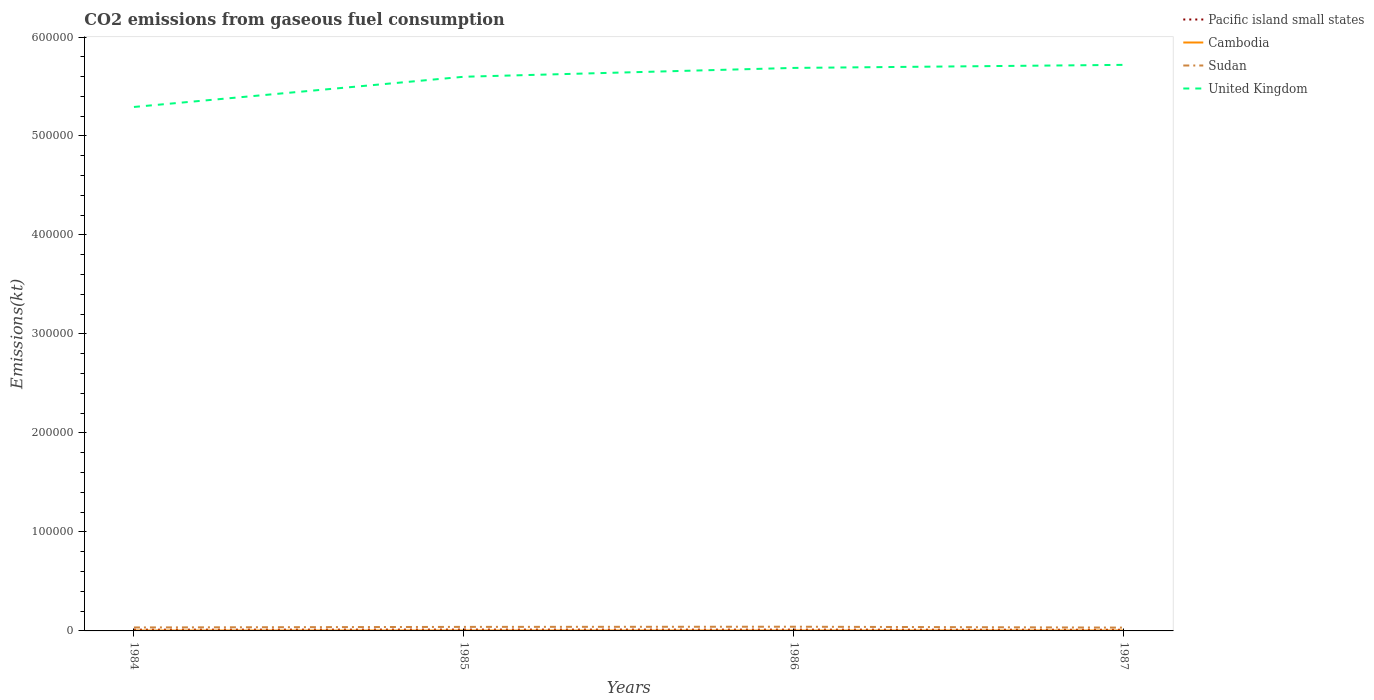How many different coloured lines are there?
Offer a terse response. 4. Does the line corresponding to Pacific island small states intersect with the line corresponding to Cambodia?
Give a very brief answer. No. Is the number of lines equal to the number of legend labels?
Offer a terse response. Yes. Across all years, what is the maximum amount of CO2 emitted in Pacific island small states?
Your answer should be compact. 1136.17. What is the total amount of CO2 emitted in United Kingdom in the graph?
Keep it short and to the point. -3091.28. What is the difference between the highest and the second highest amount of CO2 emitted in Pacific island small states?
Make the answer very short. 172.63. How many lines are there?
Give a very brief answer. 4. What is the difference between two consecutive major ticks on the Y-axis?
Ensure brevity in your answer.  1.00e+05. Are the values on the major ticks of Y-axis written in scientific E-notation?
Keep it short and to the point. No. Does the graph contain any zero values?
Make the answer very short. No. Where does the legend appear in the graph?
Keep it short and to the point. Top right. How many legend labels are there?
Provide a succinct answer. 4. How are the legend labels stacked?
Ensure brevity in your answer.  Vertical. What is the title of the graph?
Ensure brevity in your answer.  CO2 emissions from gaseous fuel consumption. Does "Monaco" appear as one of the legend labels in the graph?
Your response must be concise. No. What is the label or title of the Y-axis?
Give a very brief answer. Emissions(kt). What is the Emissions(kt) in Pacific island small states in 1984?
Your response must be concise. 1228.51. What is the Emissions(kt) of Cambodia in 1984?
Provide a succinct answer. 410.7. What is the Emissions(kt) of Sudan in 1984?
Give a very brief answer. 3505.65. What is the Emissions(kt) in United Kingdom in 1984?
Give a very brief answer. 5.29e+05. What is the Emissions(kt) in Pacific island small states in 1985?
Keep it short and to the point. 1308.8. What is the Emissions(kt) in Cambodia in 1985?
Your answer should be very brief. 418.04. What is the Emissions(kt) in Sudan in 1985?
Make the answer very short. 4074.04. What is the Emissions(kt) in United Kingdom in 1985?
Offer a very short reply. 5.60e+05. What is the Emissions(kt) of Pacific island small states in 1986?
Make the answer very short. 1268.66. What is the Emissions(kt) in Cambodia in 1986?
Provide a short and direct response. 432.71. What is the Emissions(kt) in Sudan in 1986?
Make the answer very short. 4250.05. What is the Emissions(kt) of United Kingdom in 1986?
Keep it short and to the point. 5.69e+05. What is the Emissions(kt) of Pacific island small states in 1987?
Ensure brevity in your answer.  1136.17. What is the Emissions(kt) in Cambodia in 1987?
Make the answer very short. 436.37. What is the Emissions(kt) of Sudan in 1987?
Your response must be concise. 3351.64. What is the Emissions(kt) in United Kingdom in 1987?
Provide a short and direct response. 5.72e+05. Across all years, what is the maximum Emissions(kt) of Pacific island small states?
Your answer should be compact. 1308.8. Across all years, what is the maximum Emissions(kt) of Cambodia?
Keep it short and to the point. 436.37. Across all years, what is the maximum Emissions(kt) in Sudan?
Ensure brevity in your answer.  4250.05. Across all years, what is the maximum Emissions(kt) in United Kingdom?
Provide a short and direct response. 5.72e+05. Across all years, what is the minimum Emissions(kt) of Pacific island small states?
Keep it short and to the point. 1136.17. Across all years, what is the minimum Emissions(kt) of Cambodia?
Your answer should be very brief. 410.7. Across all years, what is the minimum Emissions(kt) of Sudan?
Give a very brief answer. 3351.64. Across all years, what is the minimum Emissions(kt) in United Kingdom?
Provide a short and direct response. 5.29e+05. What is the total Emissions(kt) in Pacific island small states in the graph?
Keep it short and to the point. 4942.14. What is the total Emissions(kt) in Cambodia in the graph?
Give a very brief answer. 1697.82. What is the total Emissions(kt) in Sudan in the graph?
Keep it short and to the point. 1.52e+04. What is the total Emissions(kt) of United Kingdom in the graph?
Offer a very short reply. 2.23e+06. What is the difference between the Emissions(kt) of Pacific island small states in 1984 and that in 1985?
Keep it short and to the point. -80.29. What is the difference between the Emissions(kt) of Cambodia in 1984 and that in 1985?
Your answer should be compact. -7.33. What is the difference between the Emissions(kt) of Sudan in 1984 and that in 1985?
Ensure brevity in your answer.  -568.38. What is the difference between the Emissions(kt) of United Kingdom in 1984 and that in 1985?
Your response must be concise. -3.05e+04. What is the difference between the Emissions(kt) of Pacific island small states in 1984 and that in 1986?
Your answer should be compact. -40.15. What is the difference between the Emissions(kt) in Cambodia in 1984 and that in 1986?
Provide a succinct answer. -22. What is the difference between the Emissions(kt) of Sudan in 1984 and that in 1986?
Your answer should be compact. -744.4. What is the difference between the Emissions(kt) in United Kingdom in 1984 and that in 1986?
Give a very brief answer. -3.94e+04. What is the difference between the Emissions(kt) of Pacific island small states in 1984 and that in 1987?
Give a very brief answer. 92.34. What is the difference between the Emissions(kt) in Cambodia in 1984 and that in 1987?
Your response must be concise. -25.67. What is the difference between the Emissions(kt) in Sudan in 1984 and that in 1987?
Your answer should be very brief. 154.01. What is the difference between the Emissions(kt) of United Kingdom in 1984 and that in 1987?
Offer a very short reply. -4.25e+04. What is the difference between the Emissions(kt) of Pacific island small states in 1985 and that in 1986?
Give a very brief answer. 40.15. What is the difference between the Emissions(kt) of Cambodia in 1985 and that in 1986?
Give a very brief answer. -14.67. What is the difference between the Emissions(kt) of Sudan in 1985 and that in 1986?
Your answer should be very brief. -176.02. What is the difference between the Emissions(kt) in United Kingdom in 1985 and that in 1986?
Your answer should be compact. -8921.81. What is the difference between the Emissions(kt) of Pacific island small states in 1985 and that in 1987?
Provide a succinct answer. 172.63. What is the difference between the Emissions(kt) of Cambodia in 1985 and that in 1987?
Make the answer very short. -18.34. What is the difference between the Emissions(kt) in Sudan in 1985 and that in 1987?
Your answer should be very brief. 722.4. What is the difference between the Emissions(kt) in United Kingdom in 1985 and that in 1987?
Ensure brevity in your answer.  -1.20e+04. What is the difference between the Emissions(kt) of Pacific island small states in 1986 and that in 1987?
Give a very brief answer. 132.49. What is the difference between the Emissions(kt) in Cambodia in 1986 and that in 1987?
Offer a very short reply. -3.67. What is the difference between the Emissions(kt) of Sudan in 1986 and that in 1987?
Offer a terse response. 898.41. What is the difference between the Emissions(kt) in United Kingdom in 1986 and that in 1987?
Provide a succinct answer. -3091.28. What is the difference between the Emissions(kt) of Pacific island small states in 1984 and the Emissions(kt) of Cambodia in 1985?
Keep it short and to the point. 810.47. What is the difference between the Emissions(kt) in Pacific island small states in 1984 and the Emissions(kt) in Sudan in 1985?
Your response must be concise. -2845.53. What is the difference between the Emissions(kt) of Pacific island small states in 1984 and the Emissions(kt) of United Kingdom in 1985?
Keep it short and to the point. -5.59e+05. What is the difference between the Emissions(kt) of Cambodia in 1984 and the Emissions(kt) of Sudan in 1985?
Your answer should be compact. -3663.33. What is the difference between the Emissions(kt) in Cambodia in 1984 and the Emissions(kt) in United Kingdom in 1985?
Ensure brevity in your answer.  -5.59e+05. What is the difference between the Emissions(kt) in Sudan in 1984 and the Emissions(kt) in United Kingdom in 1985?
Your answer should be very brief. -5.56e+05. What is the difference between the Emissions(kt) of Pacific island small states in 1984 and the Emissions(kt) of Cambodia in 1986?
Give a very brief answer. 795.8. What is the difference between the Emissions(kt) of Pacific island small states in 1984 and the Emissions(kt) of Sudan in 1986?
Your answer should be very brief. -3021.54. What is the difference between the Emissions(kt) in Pacific island small states in 1984 and the Emissions(kt) in United Kingdom in 1986?
Provide a succinct answer. -5.68e+05. What is the difference between the Emissions(kt) in Cambodia in 1984 and the Emissions(kt) in Sudan in 1986?
Give a very brief answer. -3839.35. What is the difference between the Emissions(kt) in Cambodia in 1984 and the Emissions(kt) in United Kingdom in 1986?
Keep it short and to the point. -5.68e+05. What is the difference between the Emissions(kt) of Sudan in 1984 and the Emissions(kt) of United Kingdom in 1986?
Give a very brief answer. -5.65e+05. What is the difference between the Emissions(kt) of Pacific island small states in 1984 and the Emissions(kt) of Cambodia in 1987?
Offer a terse response. 792.14. What is the difference between the Emissions(kt) of Pacific island small states in 1984 and the Emissions(kt) of Sudan in 1987?
Give a very brief answer. -2123.13. What is the difference between the Emissions(kt) of Pacific island small states in 1984 and the Emissions(kt) of United Kingdom in 1987?
Ensure brevity in your answer.  -5.71e+05. What is the difference between the Emissions(kt) of Cambodia in 1984 and the Emissions(kt) of Sudan in 1987?
Your answer should be compact. -2940.93. What is the difference between the Emissions(kt) of Cambodia in 1984 and the Emissions(kt) of United Kingdom in 1987?
Your response must be concise. -5.71e+05. What is the difference between the Emissions(kt) of Sudan in 1984 and the Emissions(kt) of United Kingdom in 1987?
Provide a succinct answer. -5.68e+05. What is the difference between the Emissions(kt) in Pacific island small states in 1985 and the Emissions(kt) in Cambodia in 1986?
Keep it short and to the point. 876.1. What is the difference between the Emissions(kt) in Pacific island small states in 1985 and the Emissions(kt) in Sudan in 1986?
Provide a short and direct response. -2941.25. What is the difference between the Emissions(kt) of Pacific island small states in 1985 and the Emissions(kt) of United Kingdom in 1986?
Your answer should be very brief. -5.67e+05. What is the difference between the Emissions(kt) in Cambodia in 1985 and the Emissions(kt) in Sudan in 1986?
Make the answer very short. -3832.01. What is the difference between the Emissions(kt) of Cambodia in 1985 and the Emissions(kt) of United Kingdom in 1986?
Make the answer very short. -5.68e+05. What is the difference between the Emissions(kt) of Sudan in 1985 and the Emissions(kt) of United Kingdom in 1986?
Keep it short and to the point. -5.65e+05. What is the difference between the Emissions(kt) in Pacific island small states in 1985 and the Emissions(kt) in Cambodia in 1987?
Your answer should be compact. 872.43. What is the difference between the Emissions(kt) in Pacific island small states in 1985 and the Emissions(kt) in Sudan in 1987?
Make the answer very short. -2042.83. What is the difference between the Emissions(kt) of Pacific island small states in 1985 and the Emissions(kt) of United Kingdom in 1987?
Provide a short and direct response. -5.71e+05. What is the difference between the Emissions(kt) in Cambodia in 1985 and the Emissions(kt) in Sudan in 1987?
Provide a short and direct response. -2933.6. What is the difference between the Emissions(kt) of Cambodia in 1985 and the Emissions(kt) of United Kingdom in 1987?
Your response must be concise. -5.71e+05. What is the difference between the Emissions(kt) in Sudan in 1985 and the Emissions(kt) in United Kingdom in 1987?
Keep it short and to the point. -5.68e+05. What is the difference between the Emissions(kt) in Pacific island small states in 1986 and the Emissions(kt) in Cambodia in 1987?
Give a very brief answer. 832.28. What is the difference between the Emissions(kt) in Pacific island small states in 1986 and the Emissions(kt) in Sudan in 1987?
Offer a very short reply. -2082.98. What is the difference between the Emissions(kt) in Pacific island small states in 1986 and the Emissions(kt) in United Kingdom in 1987?
Make the answer very short. -5.71e+05. What is the difference between the Emissions(kt) in Cambodia in 1986 and the Emissions(kt) in Sudan in 1987?
Ensure brevity in your answer.  -2918.93. What is the difference between the Emissions(kt) of Cambodia in 1986 and the Emissions(kt) of United Kingdom in 1987?
Make the answer very short. -5.71e+05. What is the difference between the Emissions(kt) of Sudan in 1986 and the Emissions(kt) of United Kingdom in 1987?
Provide a short and direct response. -5.68e+05. What is the average Emissions(kt) of Pacific island small states per year?
Provide a short and direct response. 1235.54. What is the average Emissions(kt) of Cambodia per year?
Give a very brief answer. 424.46. What is the average Emissions(kt) in Sudan per year?
Offer a terse response. 3795.34. What is the average Emissions(kt) in United Kingdom per year?
Ensure brevity in your answer.  5.57e+05. In the year 1984, what is the difference between the Emissions(kt) of Pacific island small states and Emissions(kt) of Cambodia?
Provide a short and direct response. 817.81. In the year 1984, what is the difference between the Emissions(kt) in Pacific island small states and Emissions(kt) in Sudan?
Your answer should be compact. -2277.14. In the year 1984, what is the difference between the Emissions(kt) in Pacific island small states and Emissions(kt) in United Kingdom?
Provide a short and direct response. -5.28e+05. In the year 1984, what is the difference between the Emissions(kt) in Cambodia and Emissions(kt) in Sudan?
Give a very brief answer. -3094.95. In the year 1984, what is the difference between the Emissions(kt) of Cambodia and Emissions(kt) of United Kingdom?
Your response must be concise. -5.29e+05. In the year 1984, what is the difference between the Emissions(kt) in Sudan and Emissions(kt) in United Kingdom?
Make the answer very short. -5.26e+05. In the year 1985, what is the difference between the Emissions(kt) in Pacific island small states and Emissions(kt) in Cambodia?
Your answer should be very brief. 890.77. In the year 1985, what is the difference between the Emissions(kt) of Pacific island small states and Emissions(kt) of Sudan?
Ensure brevity in your answer.  -2765.23. In the year 1985, what is the difference between the Emissions(kt) in Pacific island small states and Emissions(kt) in United Kingdom?
Provide a succinct answer. -5.59e+05. In the year 1985, what is the difference between the Emissions(kt) in Cambodia and Emissions(kt) in Sudan?
Keep it short and to the point. -3656. In the year 1985, what is the difference between the Emissions(kt) in Cambodia and Emissions(kt) in United Kingdom?
Provide a short and direct response. -5.59e+05. In the year 1985, what is the difference between the Emissions(kt) of Sudan and Emissions(kt) of United Kingdom?
Provide a succinct answer. -5.56e+05. In the year 1986, what is the difference between the Emissions(kt) of Pacific island small states and Emissions(kt) of Cambodia?
Make the answer very short. 835.95. In the year 1986, what is the difference between the Emissions(kt) of Pacific island small states and Emissions(kt) of Sudan?
Offer a terse response. -2981.4. In the year 1986, what is the difference between the Emissions(kt) of Pacific island small states and Emissions(kt) of United Kingdom?
Give a very brief answer. -5.68e+05. In the year 1986, what is the difference between the Emissions(kt) of Cambodia and Emissions(kt) of Sudan?
Ensure brevity in your answer.  -3817.35. In the year 1986, what is the difference between the Emissions(kt) in Cambodia and Emissions(kt) in United Kingdom?
Provide a short and direct response. -5.68e+05. In the year 1986, what is the difference between the Emissions(kt) of Sudan and Emissions(kt) of United Kingdom?
Your answer should be very brief. -5.65e+05. In the year 1987, what is the difference between the Emissions(kt) in Pacific island small states and Emissions(kt) in Cambodia?
Ensure brevity in your answer.  699.8. In the year 1987, what is the difference between the Emissions(kt) of Pacific island small states and Emissions(kt) of Sudan?
Give a very brief answer. -2215.47. In the year 1987, what is the difference between the Emissions(kt) of Pacific island small states and Emissions(kt) of United Kingdom?
Make the answer very short. -5.71e+05. In the year 1987, what is the difference between the Emissions(kt) of Cambodia and Emissions(kt) of Sudan?
Your response must be concise. -2915.26. In the year 1987, what is the difference between the Emissions(kt) in Cambodia and Emissions(kt) in United Kingdom?
Your response must be concise. -5.71e+05. In the year 1987, what is the difference between the Emissions(kt) in Sudan and Emissions(kt) in United Kingdom?
Offer a terse response. -5.69e+05. What is the ratio of the Emissions(kt) in Pacific island small states in 1984 to that in 1985?
Provide a succinct answer. 0.94. What is the ratio of the Emissions(kt) in Cambodia in 1984 to that in 1985?
Your response must be concise. 0.98. What is the ratio of the Emissions(kt) of Sudan in 1984 to that in 1985?
Offer a very short reply. 0.86. What is the ratio of the Emissions(kt) in United Kingdom in 1984 to that in 1985?
Make the answer very short. 0.95. What is the ratio of the Emissions(kt) in Pacific island small states in 1984 to that in 1986?
Give a very brief answer. 0.97. What is the ratio of the Emissions(kt) of Cambodia in 1984 to that in 1986?
Provide a succinct answer. 0.95. What is the ratio of the Emissions(kt) of Sudan in 1984 to that in 1986?
Give a very brief answer. 0.82. What is the ratio of the Emissions(kt) in United Kingdom in 1984 to that in 1986?
Your response must be concise. 0.93. What is the ratio of the Emissions(kt) of Pacific island small states in 1984 to that in 1987?
Keep it short and to the point. 1.08. What is the ratio of the Emissions(kt) in Cambodia in 1984 to that in 1987?
Keep it short and to the point. 0.94. What is the ratio of the Emissions(kt) of Sudan in 1984 to that in 1987?
Ensure brevity in your answer.  1.05. What is the ratio of the Emissions(kt) of United Kingdom in 1984 to that in 1987?
Provide a succinct answer. 0.93. What is the ratio of the Emissions(kt) in Pacific island small states in 1985 to that in 1986?
Your answer should be very brief. 1.03. What is the ratio of the Emissions(kt) in Cambodia in 1985 to that in 1986?
Provide a short and direct response. 0.97. What is the ratio of the Emissions(kt) in Sudan in 1985 to that in 1986?
Your answer should be very brief. 0.96. What is the ratio of the Emissions(kt) of United Kingdom in 1985 to that in 1986?
Offer a terse response. 0.98. What is the ratio of the Emissions(kt) in Pacific island small states in 1985 to that in 1987?
Your answer should be compact. 1.15. What is the ratio of the Emissions(kt) in Cambodia in 1985 to that in 1987?
Offer a very short reply. 0.96. What is the ratio of the Emissions(kt) of Sudan in 1985 to that in 1987?
Give a very brief answer. 1.22. What is the ratio of the Emissions(kt) in United Kingdom in 1985 to that in 1987?
Offer a terse response. 0.98. What is the ratio of the Emissions(kt) of Pacific island small states in 1986 to that in 1987?
Offer a terse response. 1.12. What is the ratio of the Emissions(kt) of Sudan in 1986 to that in 1987?
Offer a terse response. 1.27. What is the difference between the highest and the second highest Emissions(kt) in Pacific island small states?
Provide a short and direct response. 40.15. What is the difference between the highest and the second highest Emissions(kt) in Cambodia?
Provide a short and direct response. 3.67. What is the difference between the highest and the second highest Emissions(kt) of Sudan?
Keep it short and to the point. 176.02. What is the difference between the highest and the second highest Emissions(kt) in United Kingdom?
Make the answer very short. 3091.28. What is the difference between the highest and the lowest Emissions(kt) of Pacific island small states?
Give a very brief answer. 172.63. What is the difference between the highest and the lowest Emissions(kt) in Cambodia?
Keep it short and to the point. 25.67. What is the difference between the highest and the lowest Emissions(kt) of Sudan?
Make the answer very short. 898.41. What is the difference between the highest and the lowest Emissions(kt) of United Kingdom?
Your answer should be very brief. 4.25e+04. 